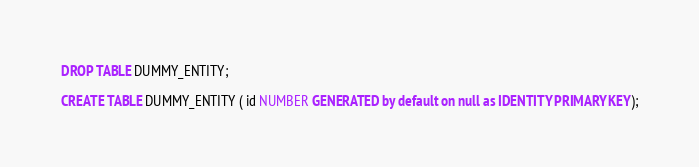Convert code to text. <code><loc_0><loc_0><loc_500><loc_500><_SQL_>DROP TABLE DUMMY_ENTITY;

CREATE TABLE DUMMY_ENTITY ( id NUMBER GENERATED by default on null as IDENTITY PRIMARY KEY);</code> 